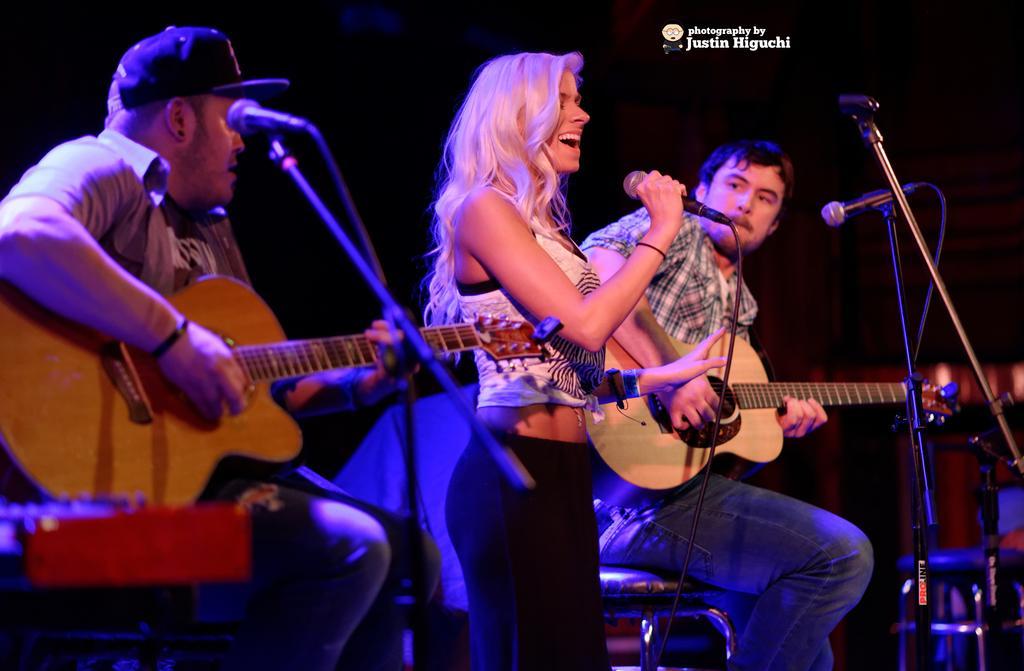Could you give a brief overview of what you see in this image? There are 3 people on a stage. The two persons are sitting on a chairs. In the center we have a woman. She is standing. She is singing a song. The remaining people are playing a musical instruments. 